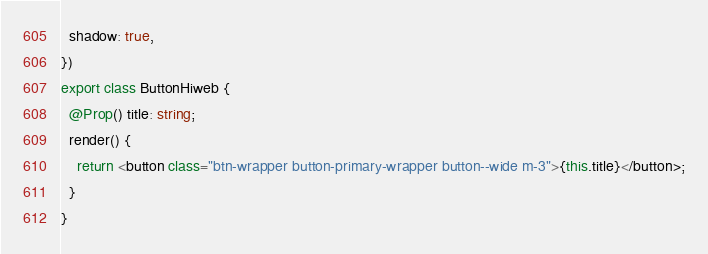<code> <loc_0><loc_0><loc_500><loc_500><_TypeScript_>  shadow: true,
})
export class ButtonHiweb {
  @Prop() title: string;
  render() {
    return <button class="btn-wrapper button-primary-wrapper button--wide m-3">{this.title}</button>;
  }
}
</code> 